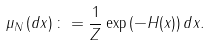<formula> <loc_0><loc_0><loc_500><loc_500>\mu _ { N } \left ( d x \right ) \colon = \frac { 1 } { Z } \exp \left ( - H ( x ) \right ) d x .</formula> 